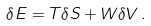Convert formula to latex. <formula><loc_0><loc_0><loc_500><loc_500>\delta E = T \delta S + W \delta V \, .</formula> 